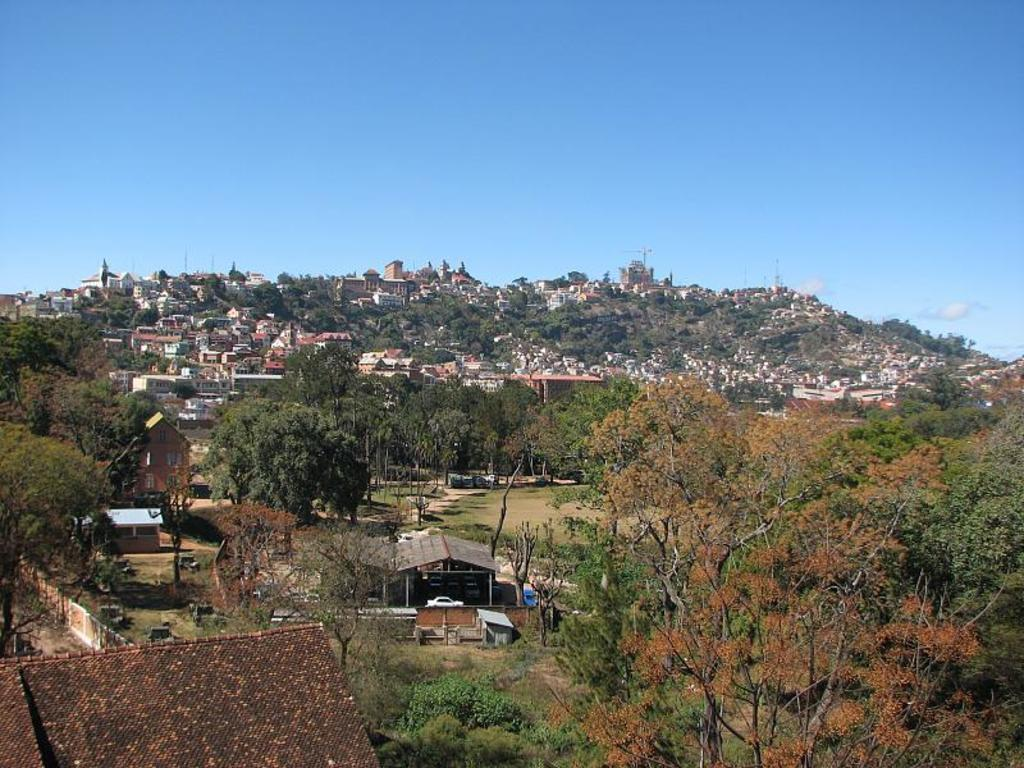What type of natural elements can be seen in the image? There are multiple trees in the image. What type of man-made structures are present in the image? There are multiple buildings in the image. What is the color of the car in the center of the image? The car in the center of the image is white. What can be seen in the background of the image? The sky is visible in the background of the image, and clouds are present. Can you tell me how many people are swimming in the image? There are no people swimming in the image; it features trees, buildings, a white car, and a sky with clouds. 